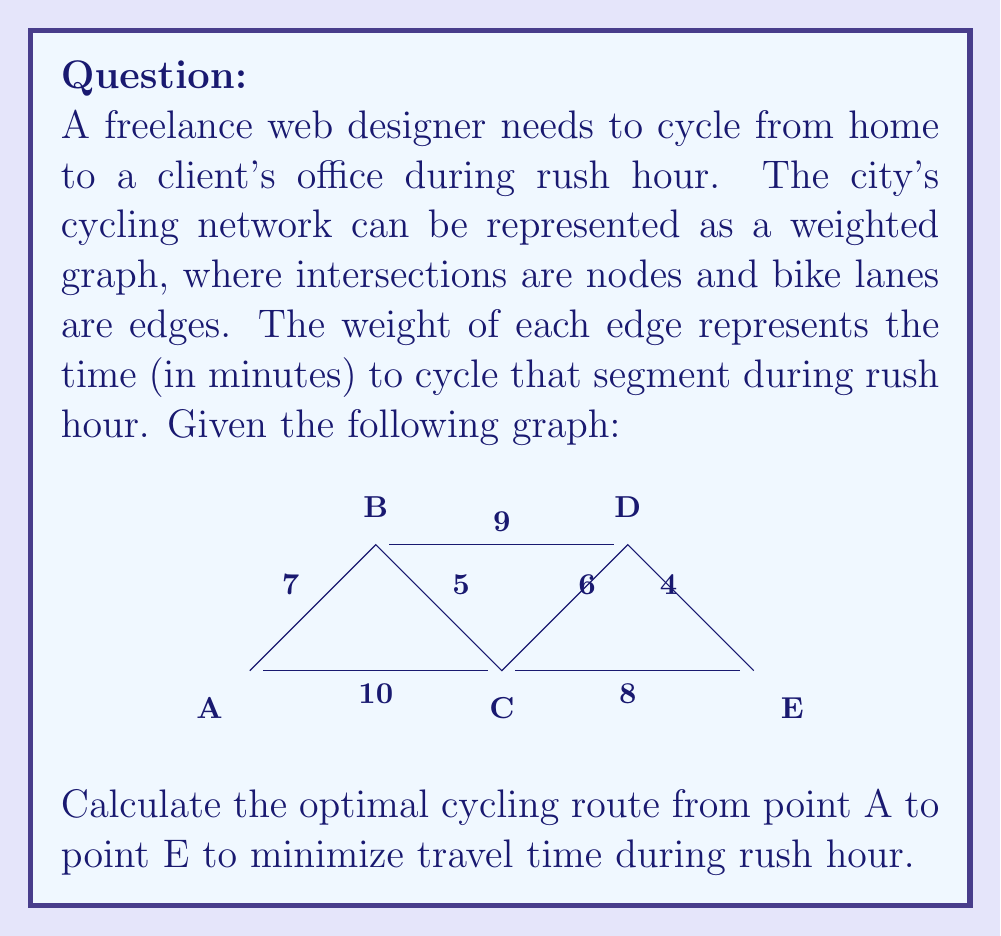Teach me how to tackle this problem. To solve this problem, we need to find the shortest path from node A to node E in the given weighted graph. We can use Dijkstra's algorithm to find the shortest path.

Step 1: Initialize distances
Set distance to A as 0 and all other nodes as infinity.
$d(A) = 0$, $d(B) = d(C) = d(D) = d(E) = \infty$

Step 2: Start from node A
Compare paths:
A to B: $d(B) = \min(\infty, 0 + 7) = 7$
A to C: $d(C) = \min(\infty, 0 + 10) = 10$

Step 3: Move to node B (smallest distance)
Compare paths:
B to C: $d(C) = \min(10, 7 + 5) = 10$
B to D: $d(D) = \min(\infty, 7 + 9) = 16$

Step 4: Move to node C
Compare paths:
C to D: $d(D) = \min(16, 10 + 6) = 16$
C to E: $d(E) = \min(\infty, 10 + 8) = 18$

Step 5: Move to node D
Compare path:
D to E: $d(E) = \min(18, 16 + 4) = 18$

The algorithm terminates as we've reached node E.

The shortest path is A -> C -> E with a total distance of 18 minutes.
Answer: The optimal cycling route from A to E is A -> C -> E, with a total travel time of 18 minutes. 